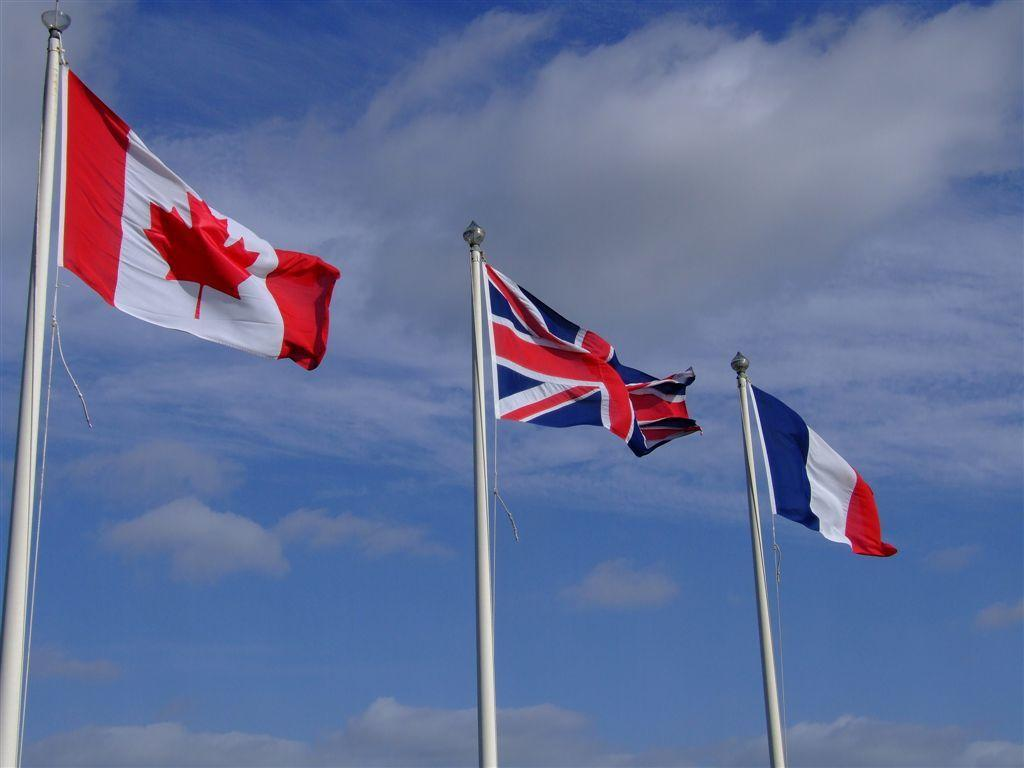How many flags are present in the image? There are three flags in the image. Where are the flags located in relation to the image? The flags are in the front of the image. What can be seen in the background of the image? There is sky visible in the background of the image. What type of science experiment is being conducted with the volleyball in the image? There is no volleyball present in the image, and therefore no science experiment involving a volleyball can be observed. 